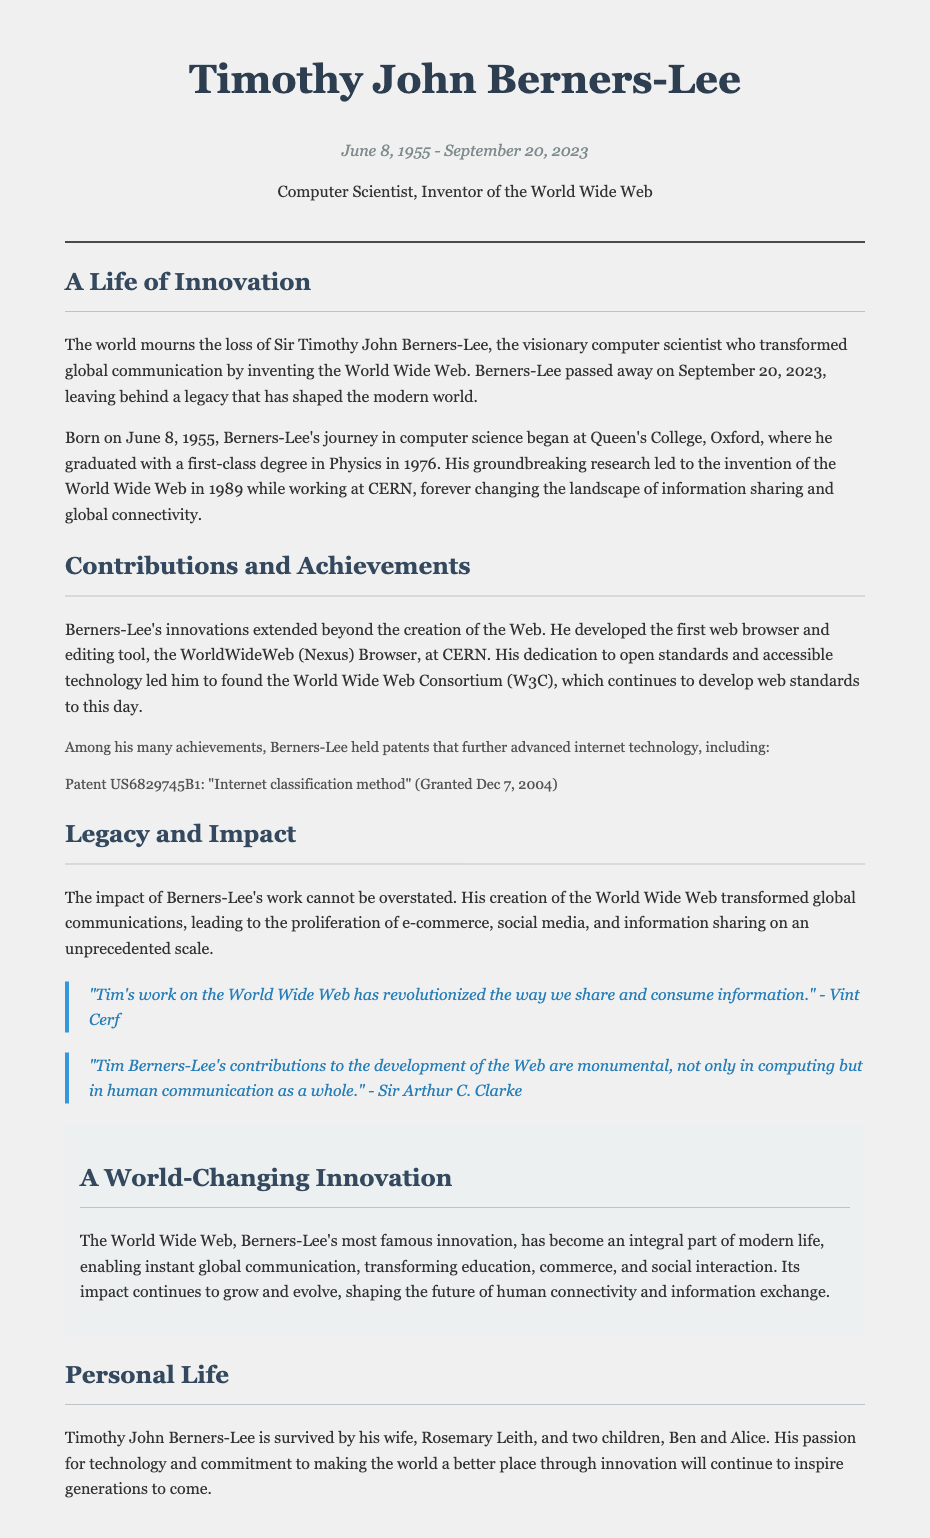What was Timothy John Berners-Lee's contribution to global communication? Timothy John Berners-Lee invented the World Wide Web, which transformed global communication.
Answer: World Wide Web When was Berners-Lee born? The document states that Berners-Lee was born on June 8, 1955.
Answer: June 8, 1955 What patent did Berners-Lee hold related to internet technology? The document lists a patent held by Berners-Lee: US6829745B1 for "Internet classification method" granted on December 7, 2004.
Answer: US6829745B1 Who are the survivors of Timothy John Berners-Lee? The document mentions his wife and two children as the survivors.
Answer: Rosemary Leith, Ben, and Alice Who endorsed Berners-Lee's contributions to the Web? The document includes endorsements from Vint Cerf and Sir Arthur C. Clarke regarding Berners-Lee's contributions.
Answer: Vint Cerf, Sir Arthur C. Clarke What organization did Berners-Lee found? According to the document, he founded the World Wide Web Consortium (W3C).
Answer: World Wide Web Consortium What was the date of Berners-Lee's passing? The document states that he passed away on September 20, 2023.
Answer: September 20, 2023 What was the main focus of Berners-Lee's innovations? The focus of Berners-Lee's innovations was on open standards and accessible technology.
Answer: Open standards and accessible technology How did Berners-Lee's work affect e-commerce? The impact of Berners-Lee's work led to the proliferation of e-commerce on an unprecedented scale.
Answer: Proliferation of e-commerce 